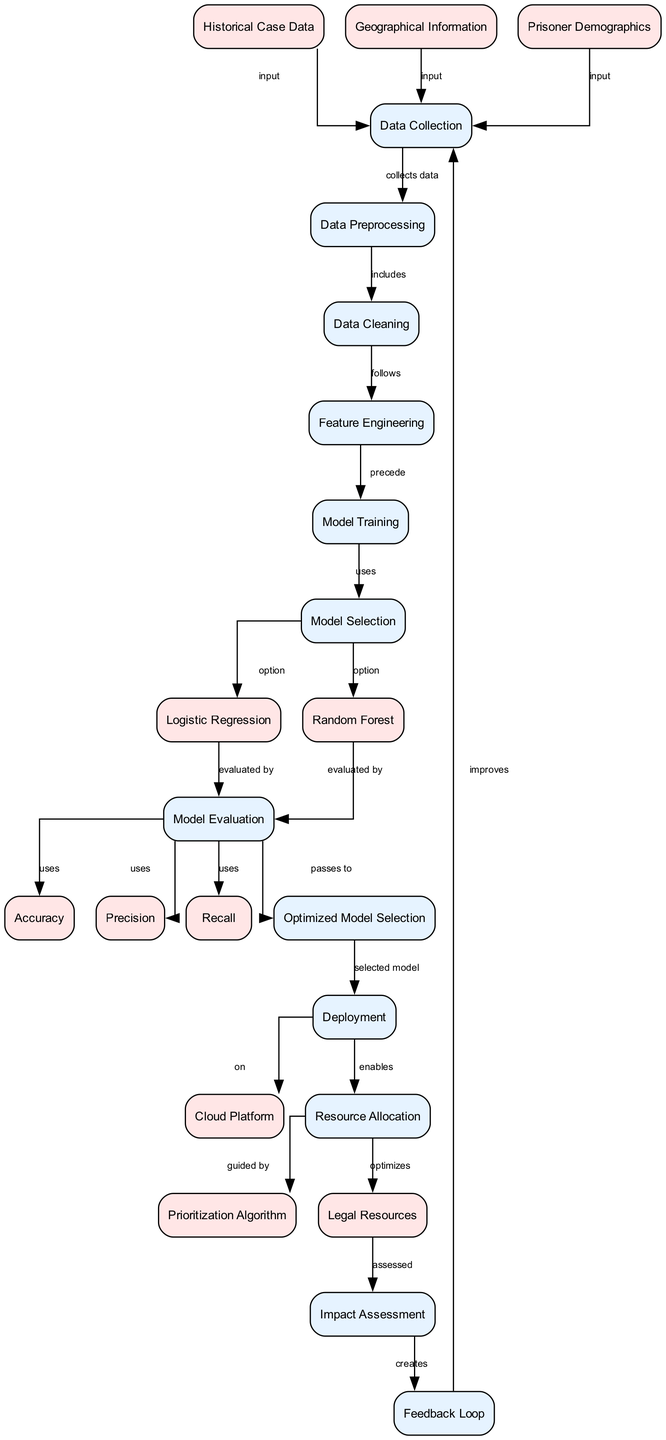What type of data inputs are used in the diagram? The diagram specifies three types of data inputs which are Historical Case Data, Geographical Information, and Prisoner Demographics, all feeding into the Data Collection process. This can be identified through the edges leading from these nodes to the Data Collection node in the diagram.
Answer: Historical Case Data, Geographical Information, Prisoner Demographics How many processes are represented in the diagram? The diagram contains a total of eight distinct processes: Data Collection, Data Preprocessing, Data Cleaning, Feature Engineering, Model Training, Model Selection, Model Evaluation, and Impact Assessment. These processes can be counted as each distinct node labeled as a process in the diagram.
Answer: Eight What is the primary output of the Model Evaluation process? The outputs from the Model Evaluation process are Accuracy, Precision, and Recall, as indicated by the edges leading from the Model Evaluation node to these three data nodes.
Answer: Accuracy, Precision, Recall Which model option follows Model Selection? The diagram indicates that after the Model Selection process, two model options are presented: Logistic Regression and Random Forest, as shown by the edges from Model Selection to these respective models. Either option could be selected for the training process to follow.
Answer: Logistic Regression, Random Forest What process comes after Deployment? The diagram shows that the process of Resource Allocation follows Deployment. This can be traced from the Deployment node to the next node labeled as Resource Allocation, indicating the sequence of operations.
Answer: Resource Allocation What does the Feedback Loop create? The Feedback Loop creates an improvement back into the Data Collection process as illustrated by the edge leading from Feedback Loop back to Data Collection in the diagram. This indicates a cyclical mechanism for optimizing resources based on evaluation outcomes.
Answer: Improvement In which node is the prioritization algorithm used? The prioritization algorithm is used within the Resource Allocation process, as shown by the edge connecting Resource Allocation to the Prioritization Algorithm data node, which guides the allocation of legal resources.
Answer: Resource Allocation How many edges connect inputs to the Data Collection process? There are three edges connecting the inputs to the Data Collection process, corresponding to the three input nodes: Historical Case Data, Geographical Information, and Prisoner Demographics. Each input is directed towards this process which collects the various data inputs.
Answer: Three 